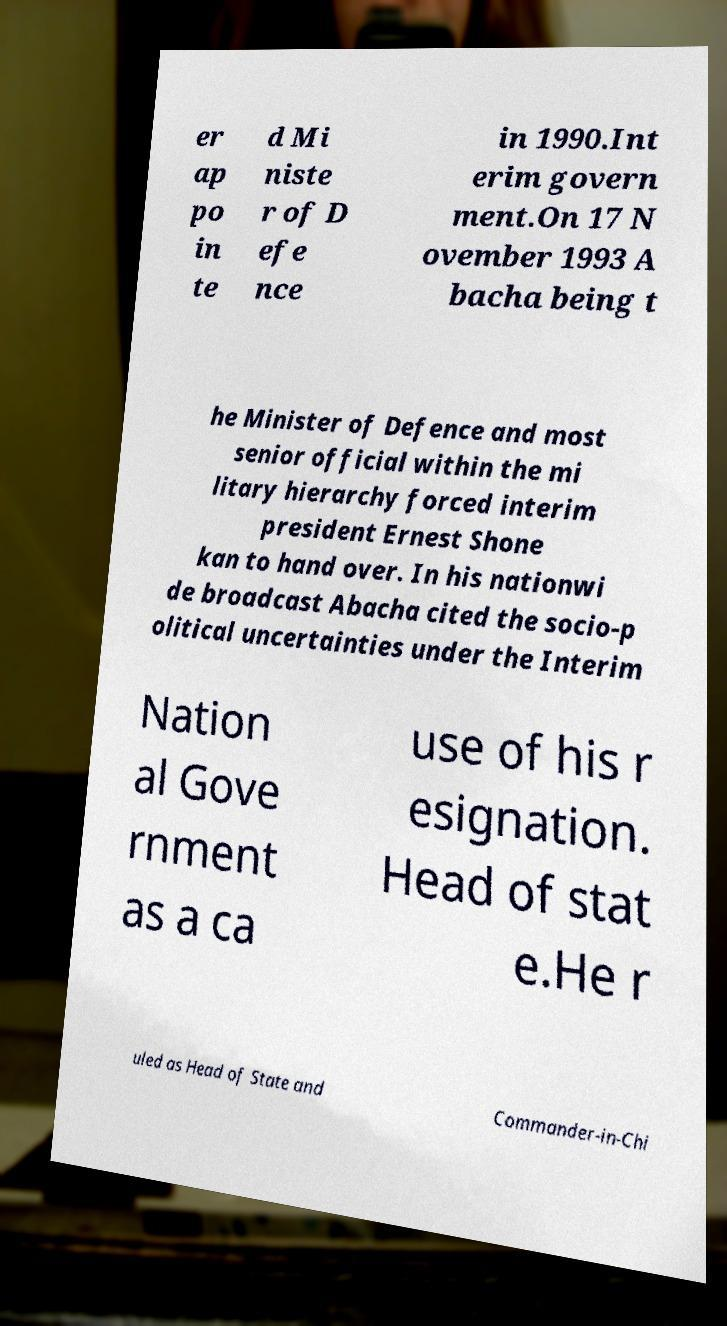What messages or text are displayed in this image? I need them in a readable, typed format. er ap po in te d Mi niste r of D efe nce in 1990.Int erim govern ment.On 17 N ovember 1993 A bacha being t he Minister of Defence and most senior official within the mi litary hierarchy forced interim president Ernest Shone kan to hand over. In his nationwi de broadcast Abacha cited the socio-p olitical uncertainties under the Interim Nation al Gove rnment as a ca use of his r esignation. Head of stat e.He r uled as Head of State and Commander-in-Chi 